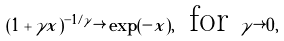<formula> <loc_0><loc_0><loc_500><loc_500>( 1 + \gamma x ) ^ { - 1 / \gamma } \rightarrow \exp ( - x ) , \, \text { for } \gamma \rightarrow 0 ,</formula> 